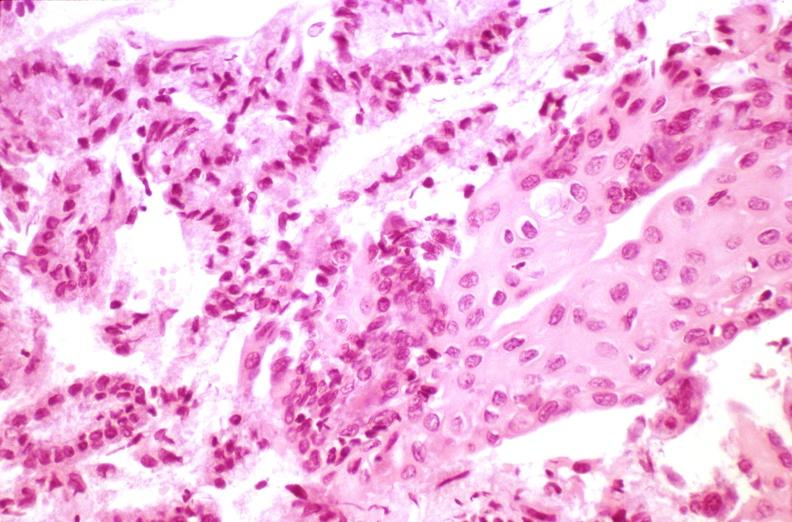where is this from?
Answer the question using a single word or phrase. Female reproductive system 